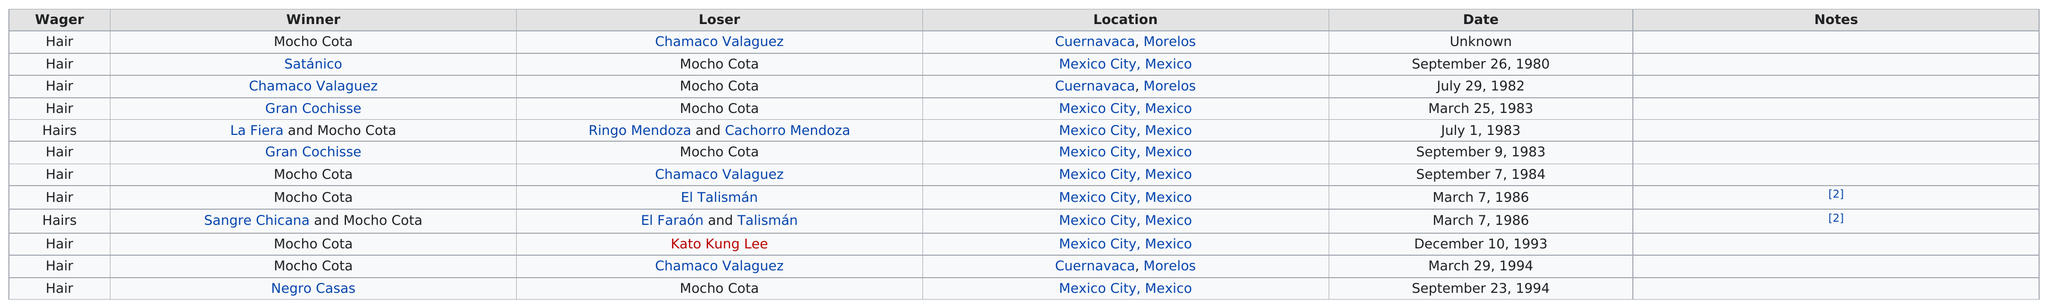Give some essential details in this illustration. There were four Mocha Cota matches held in Mexico City in 1983 or 1984. Se ha publicado en varias ocasiones que el ganador de la carrera de motocross es Mochó Cota en un número de 7 ocasiones. Mocho Cota won 5 consecutive fights. Mocho Cota lost to Chamaco Valaguez a total of 1 time. It is expected that another wrestler will emerge victorious in a match held in Cuernavaca, aside from Mocho Cota. Specifically, Chamaco Valaguez is expected to deliver a successful performance. 